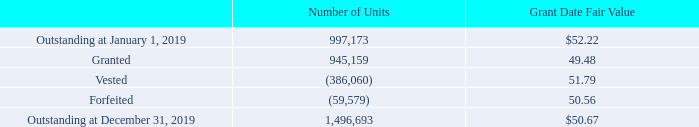Restricted Stock Awards
We present below a summary of changes in unvested units of restricted stock during 2019:
The Company recorded equity-based compensation expense related to restricted stock and RSUs (collectively “restricted stock awards”) of $31.8 million, $19.9 million, and $16.2 million in 2019, 2018 and 2017, respectively. The total fair value of restricted stock awards vested in 2019, 2018 and 2017, based on market value at the vesting dates was $18.2 million, $18.1 million, and $18.8 million, respectively. The weighted average grant-date fair value of RSUs granted during fiscal year 2019, 2018 and 2017 was $49.48, $51.72 and $49.01, respectively. As of December 31, 2019, unrecognized compensation cost related to unvested RSU totaled $47.5 million and is expected to be recognized over a weighted average period of approximately 2.5 years. In January 2017, we elected to recognize forfeitures of equity-based payments as they occur.
awards”) of $31.8 million, $19.9 million, and $16.2 million in 2019, 2018 and 2017, respectively. The total fair value of restricted
stock awards vested in 2019, 2018 and 2017, based on market value at the vesting dates was $18.2 million, $18.1 million, and $18.8
million, respectively. The weighted average grant-date fair value of RSUs granted during fiscal year 2019, 2018 and 2017 was $49.48,
$51.72 and $49.01, respectively. As of December 31, 2019, unrecognized compensation cost related to unvested RSU totaled $47.5
million and is expected to be recognized over a weighted average period of approximately 2.5 years. In January 2017, we elected to
recognize forfeitures of equity-based payments as they occur.
Included in RSU grants for the year ended December 31, 2019 are 282,327 units that have performance-based vesting criteria. The
performance criteria are tied to our financial performance. As of December 31, 2019, the associated equity-based compensation
expense has been recognized for the portion of the award attributable to the 2019 performance criteria.
What is the outstanding number of units at the beginning of 2019? 997,173. What the number of forfeited shares in 2019? 59,579. What is the outstanding number of shares at the end of 2019? 1,496,693. What is the value difference between granted share and vested share? 51.79-49.48
Answer: 2.31. What is the change in the outstanding number of shares between the beginning and end of the year 2019? 1,496,693-997,173
Answer: 499520. What is the difference in grant date fair value between the vested stocks and the forfeited stocks? 51.79-50.56
Answer: 1.23. 